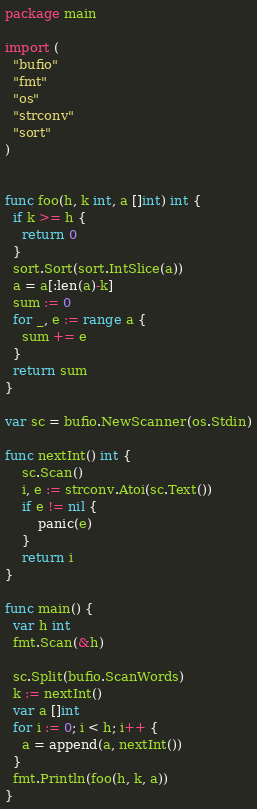Convert code to text. <code><loc_0><loc_0><loc_500><loc_500><_Go_>package main

import (
  "bufio"
  "fmt"
  "os"
  "strconv"
  "sort"
)


func foo(h, k int, a []int) int {
  if k >= h {
    return 0
  }
  sort.Sort(sort.IntSlice(a))
  a = a[:len(a)-k]
  sum := 0
  for _, e := range a {
    sum += e
  }
  return sum
}

var sc = bufio.NewScanner(os.Stdin)

func nextInt() int {
    sc.Scan()
    i, e := strconv.Atoi(sc.Text())
    if e != nil {
        panic(e)
    }
    return i
}

func main() {
  var h int
  fmt.Scan(&h)
  
  sc.Split(bufio.ScanWords)
  k := nextInt()
  var a []int
  for i := 0; i < h; i++ {
    a = append(a, nextInt())
  }
  fmt.Println(foo(h, k, a))
}
</code> 